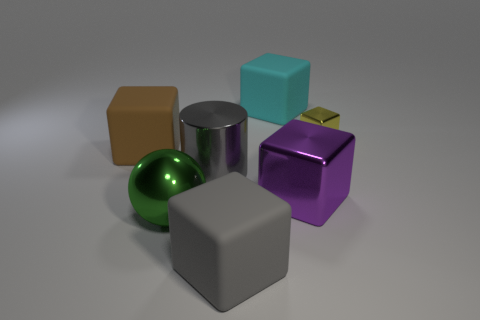Add 3 large metal blocks. How many objects exist? 10 Subtract all blocks. How many objects are left? 2 Add 1 big cyan metal blocks. How many big cyan metal blocks exist? 1 Subtract 0 red cylinders. How many objects are left? 7 Subtract all large purple metal blocks. Subtract all gray metal cubes. How many objects are left? 6 Add 2 large gray objects. How many large gray objects are left? 4 